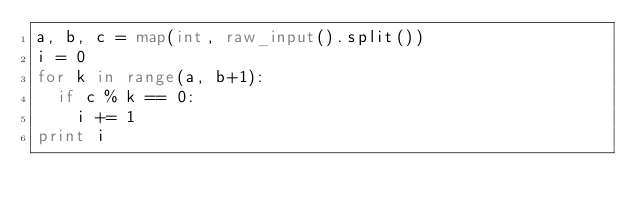<code> <loc_0><loc_0><loc_500><loc_500><_Python_>a, b, c = map(int, raw_input().split())
i = 0
for k in range(a, b+1):
	if c % k == 0:
		i += 1
print i</code> 